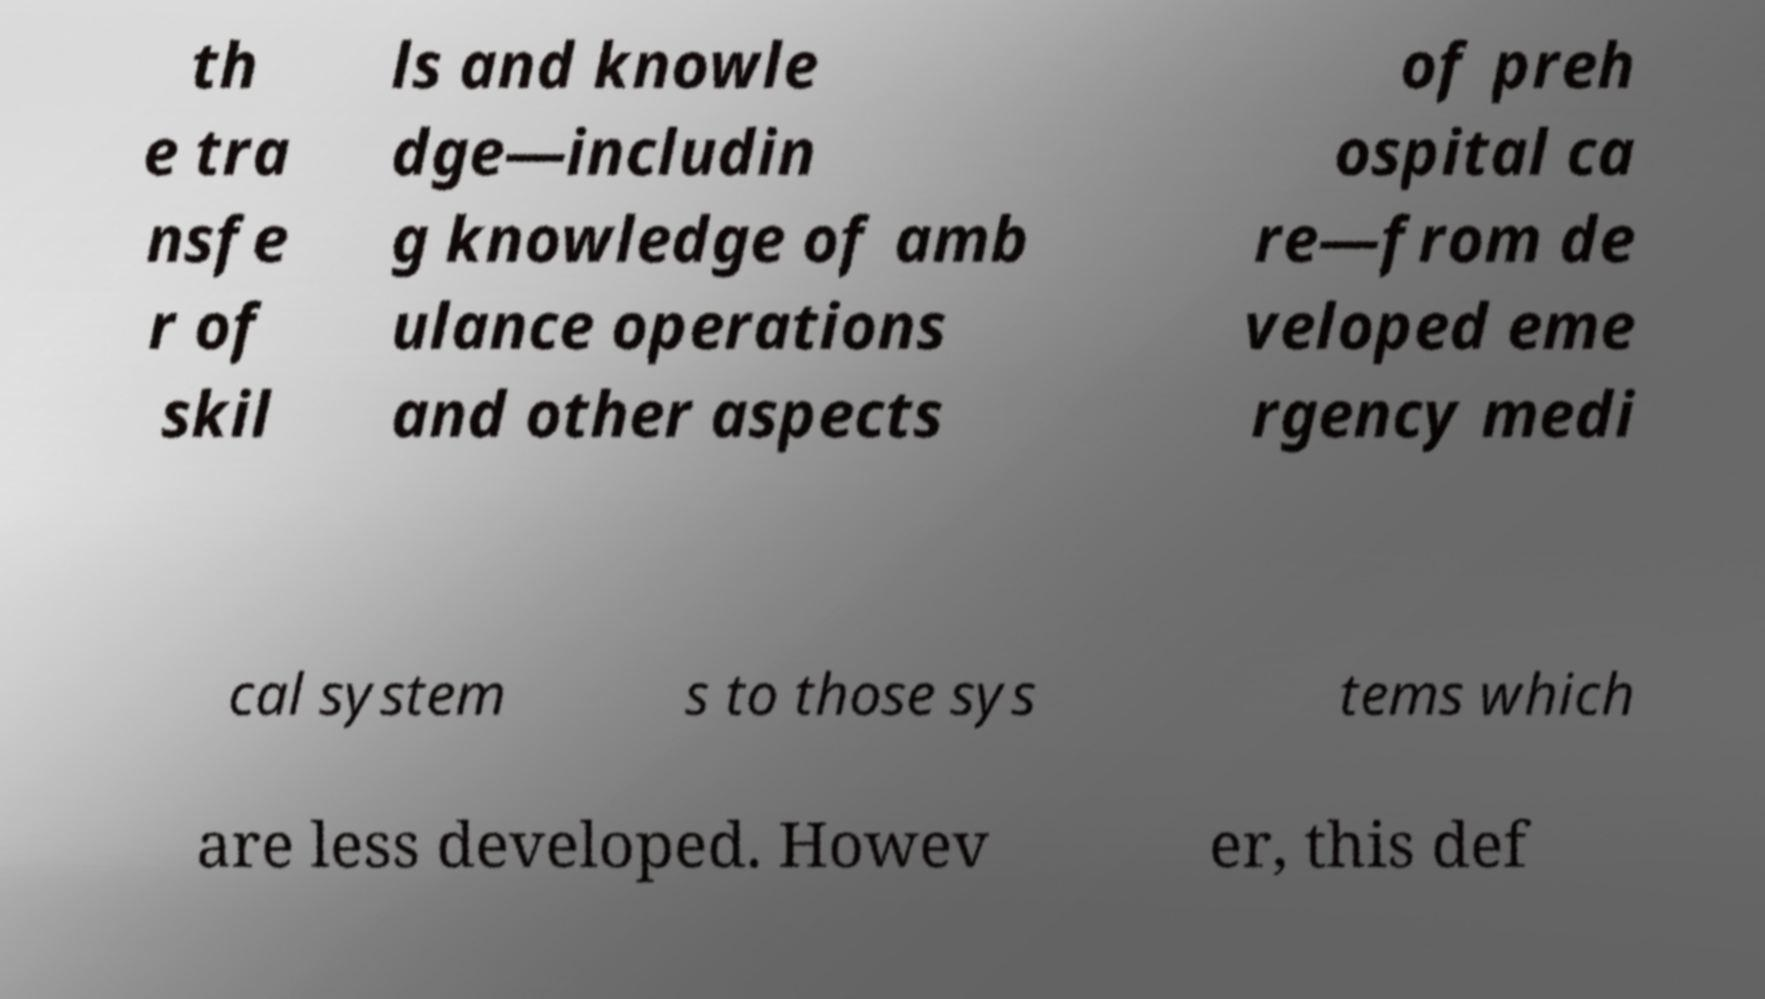What messages or text are displayed in this image? I need them in a readable, typed format. th e tra nsfe r of skil ls and knowle dge—includin g knowledge of amb ulance operations and other aspects of preh ospital ca re—from de veloped eme rgency medi cal system s to those sys tems which are less developed. Howev er, this def 